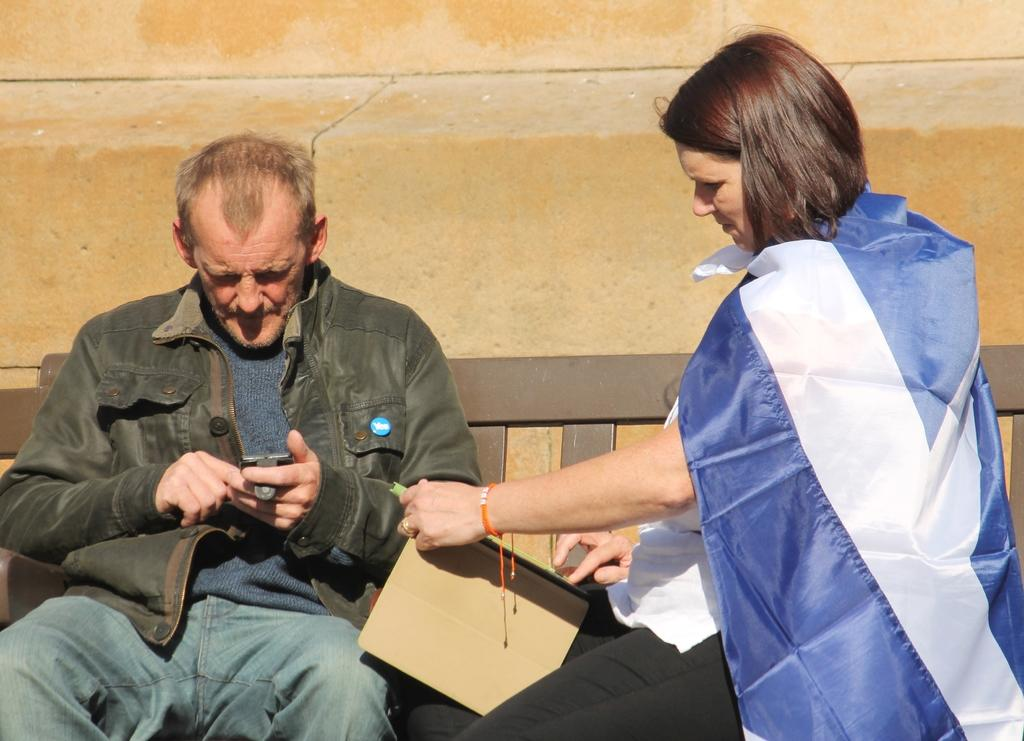How many people are in the image? There are two persons in the image. What are the persons doing in the image? The persons are sitting. What are the persons holding in the image? The persons are holding objects. What can be seen in the background of the image? There is a wall in the background of the image. What type of stocking is the person wearing on their head in the image? There is no person wearing a stocking on their head in the image. How fast are the persons running in the image? The persons are not running in the image; they are sitting. 